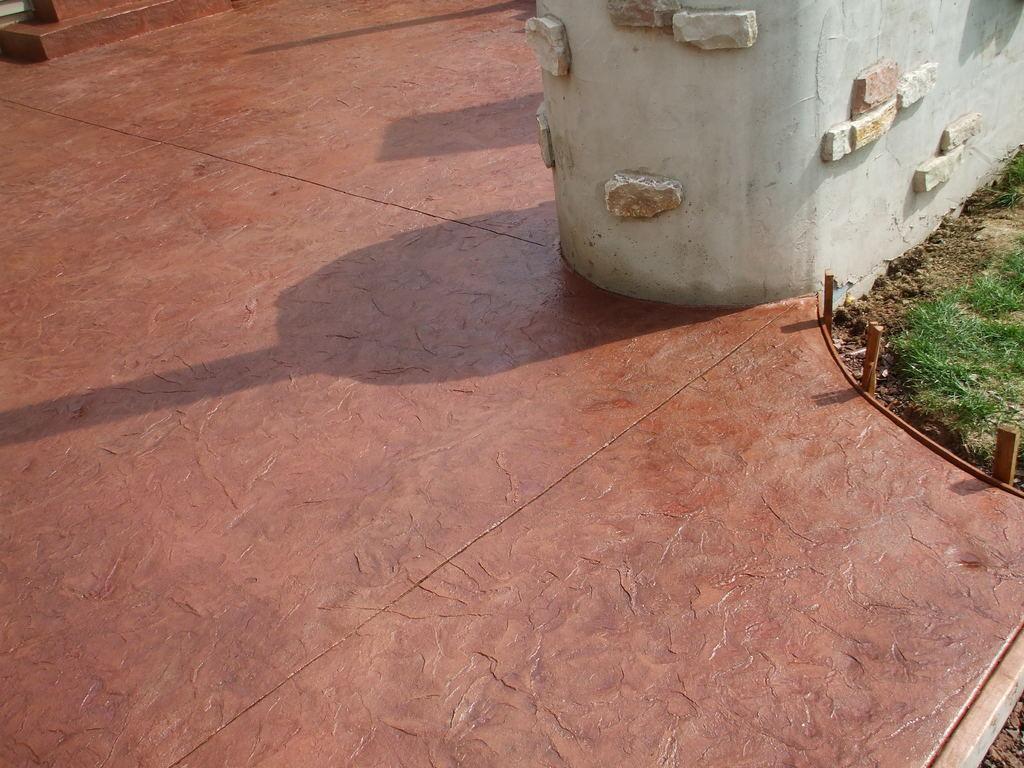Can you describe this image briefly? In the picture we can see a path which is brown in color and beside it, we can see a part of the grass surface and a wall which is white in color and some stones to it. 